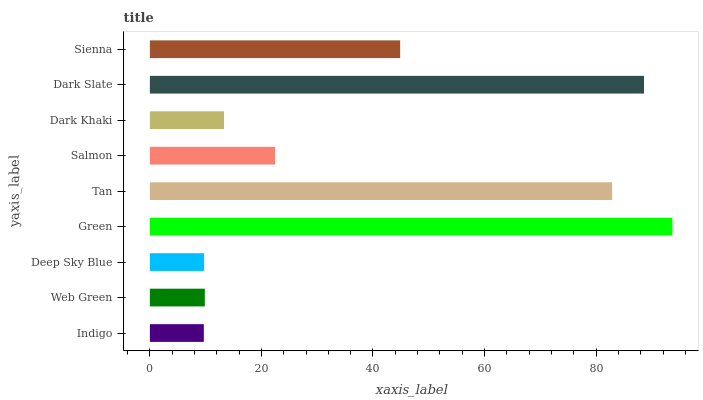Is Indigo the minimum?
Answer yes or no. Yes. Is Green the maximum?
Answer yes or no. Yes. Is Web Green the minimum?
Answer yes or no. No. Is Web Green the maximum?
Answer yes or no. No. Is Web Green greater than Indigo?
Answer yes or no. Yes. Is Indigo less than Web Green?
Answer yes or no. Yes. Is Indigo greater than Web Green?
Answer yes or no. No. Is Web Green less than Indigo?
Answer yes or no. No. Is Salmon the high median?
Answer yes or no. Yes. Is Salmon the low median?
Answer yes or no. Yes. Is Green the high median?
Answer yes or no. No. Is Web Green the low median?
Answer yes or no. No. 